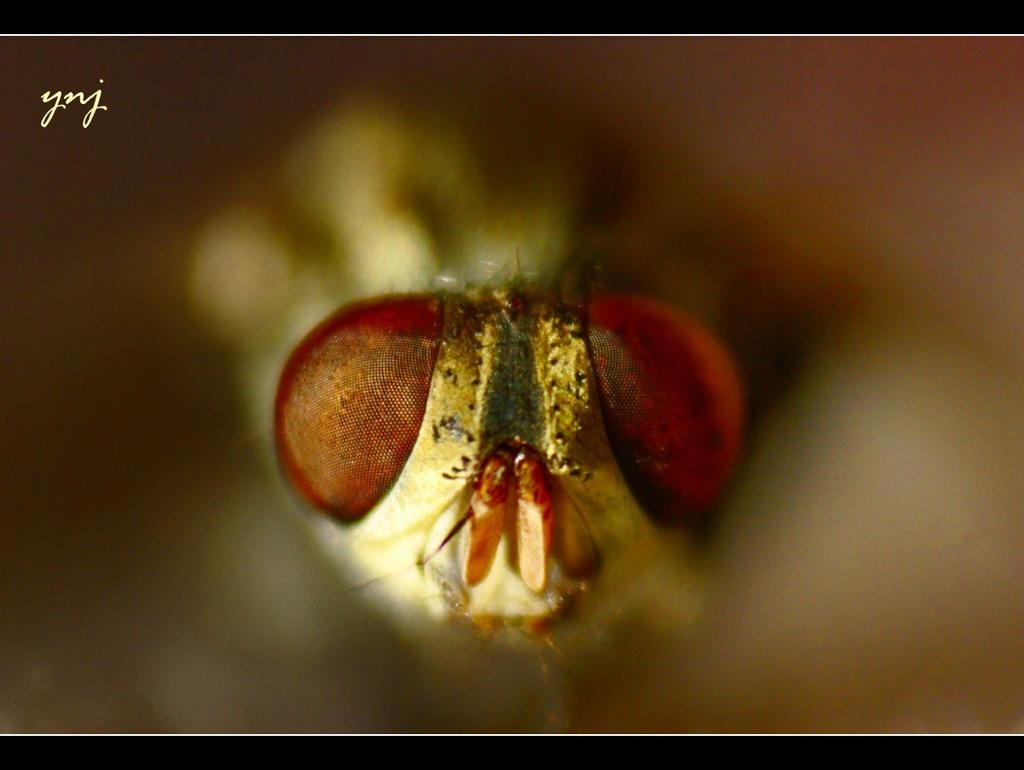What type of creature is present in the image? There is an insect in the image. What type of cart is being used to transport the vegetables during the holiday in the image? There is no cart, vegetables, or holiday present in the image; it only features an insect. 